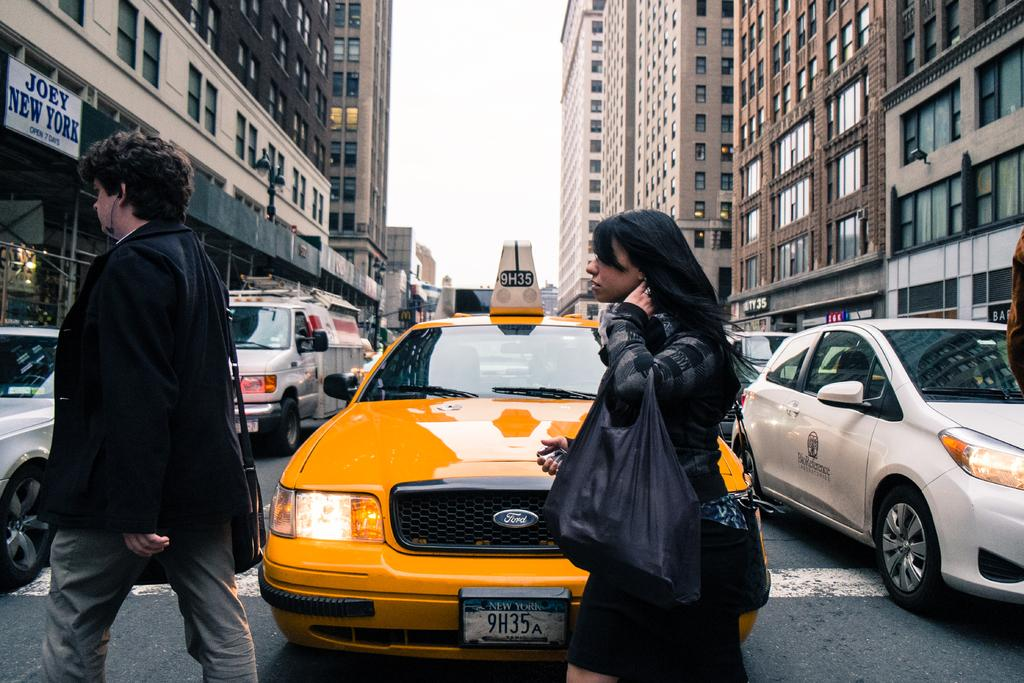<image>
Offer a succinct explanation of the picture presented. Two people cross a busy city street in front of a taxi with New York license plate 9H35A, close to a store called Joey New York. 